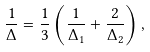<formula> <loc_0><loc_0><loc_500><loc_500>\frac { 1 } { \Delta } = \frac { 1 } { 3 } \left ( \frac { 1 } { \Delta _ { 1 } } + \frac { 2 } { \Delta _ { 2 } } \right ) ,</formula> 